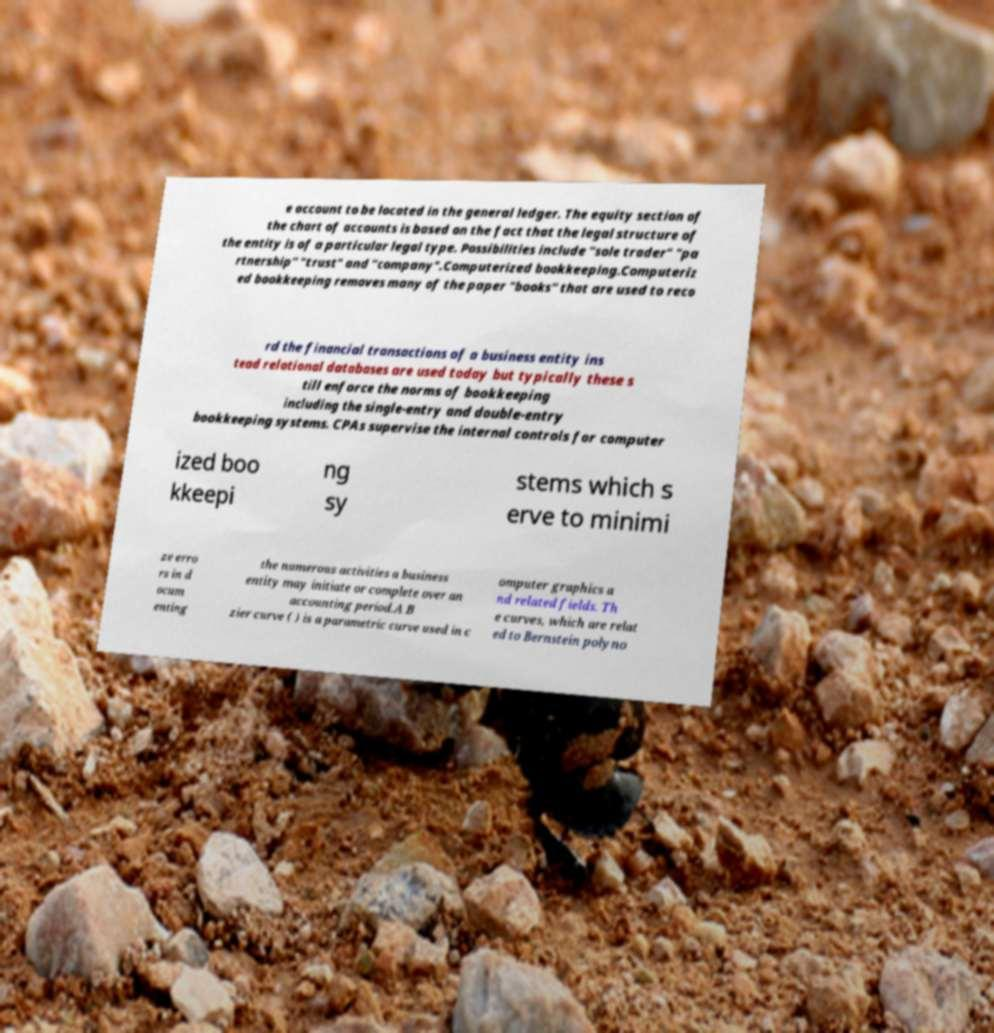What messages or text are displayed in this image? I need them in a readable, typed format. e account to be located in the general ledger. The equity section of the chart of accounts is based on the fact that the legal structure of the entity is of a particular legal type. Possibilities include "sole trader" "pa rtnership" "trust" and "company".Computerized bookkeeping.Computeriz ed bookkeeping removes many of the paper "books" that are used to reco rd the financial transactions of a business entity ins tead relational databases are used today but typically these s till enforce the norms of bookkeeping including the single-entry and double-entry bookkeeping systems. CPAs supervise the internal controls for computer ized boo kkeepi ng sy stems which s erve to minimi ze erro rs in d ocum enting the numerous activities a business entity may initiate or complete over an accounting period.A B zier curve ( ) is a parametric curve used in c omputer graphics a nd related fields. Th e curves, which are relat ed to Bernstein polyno 